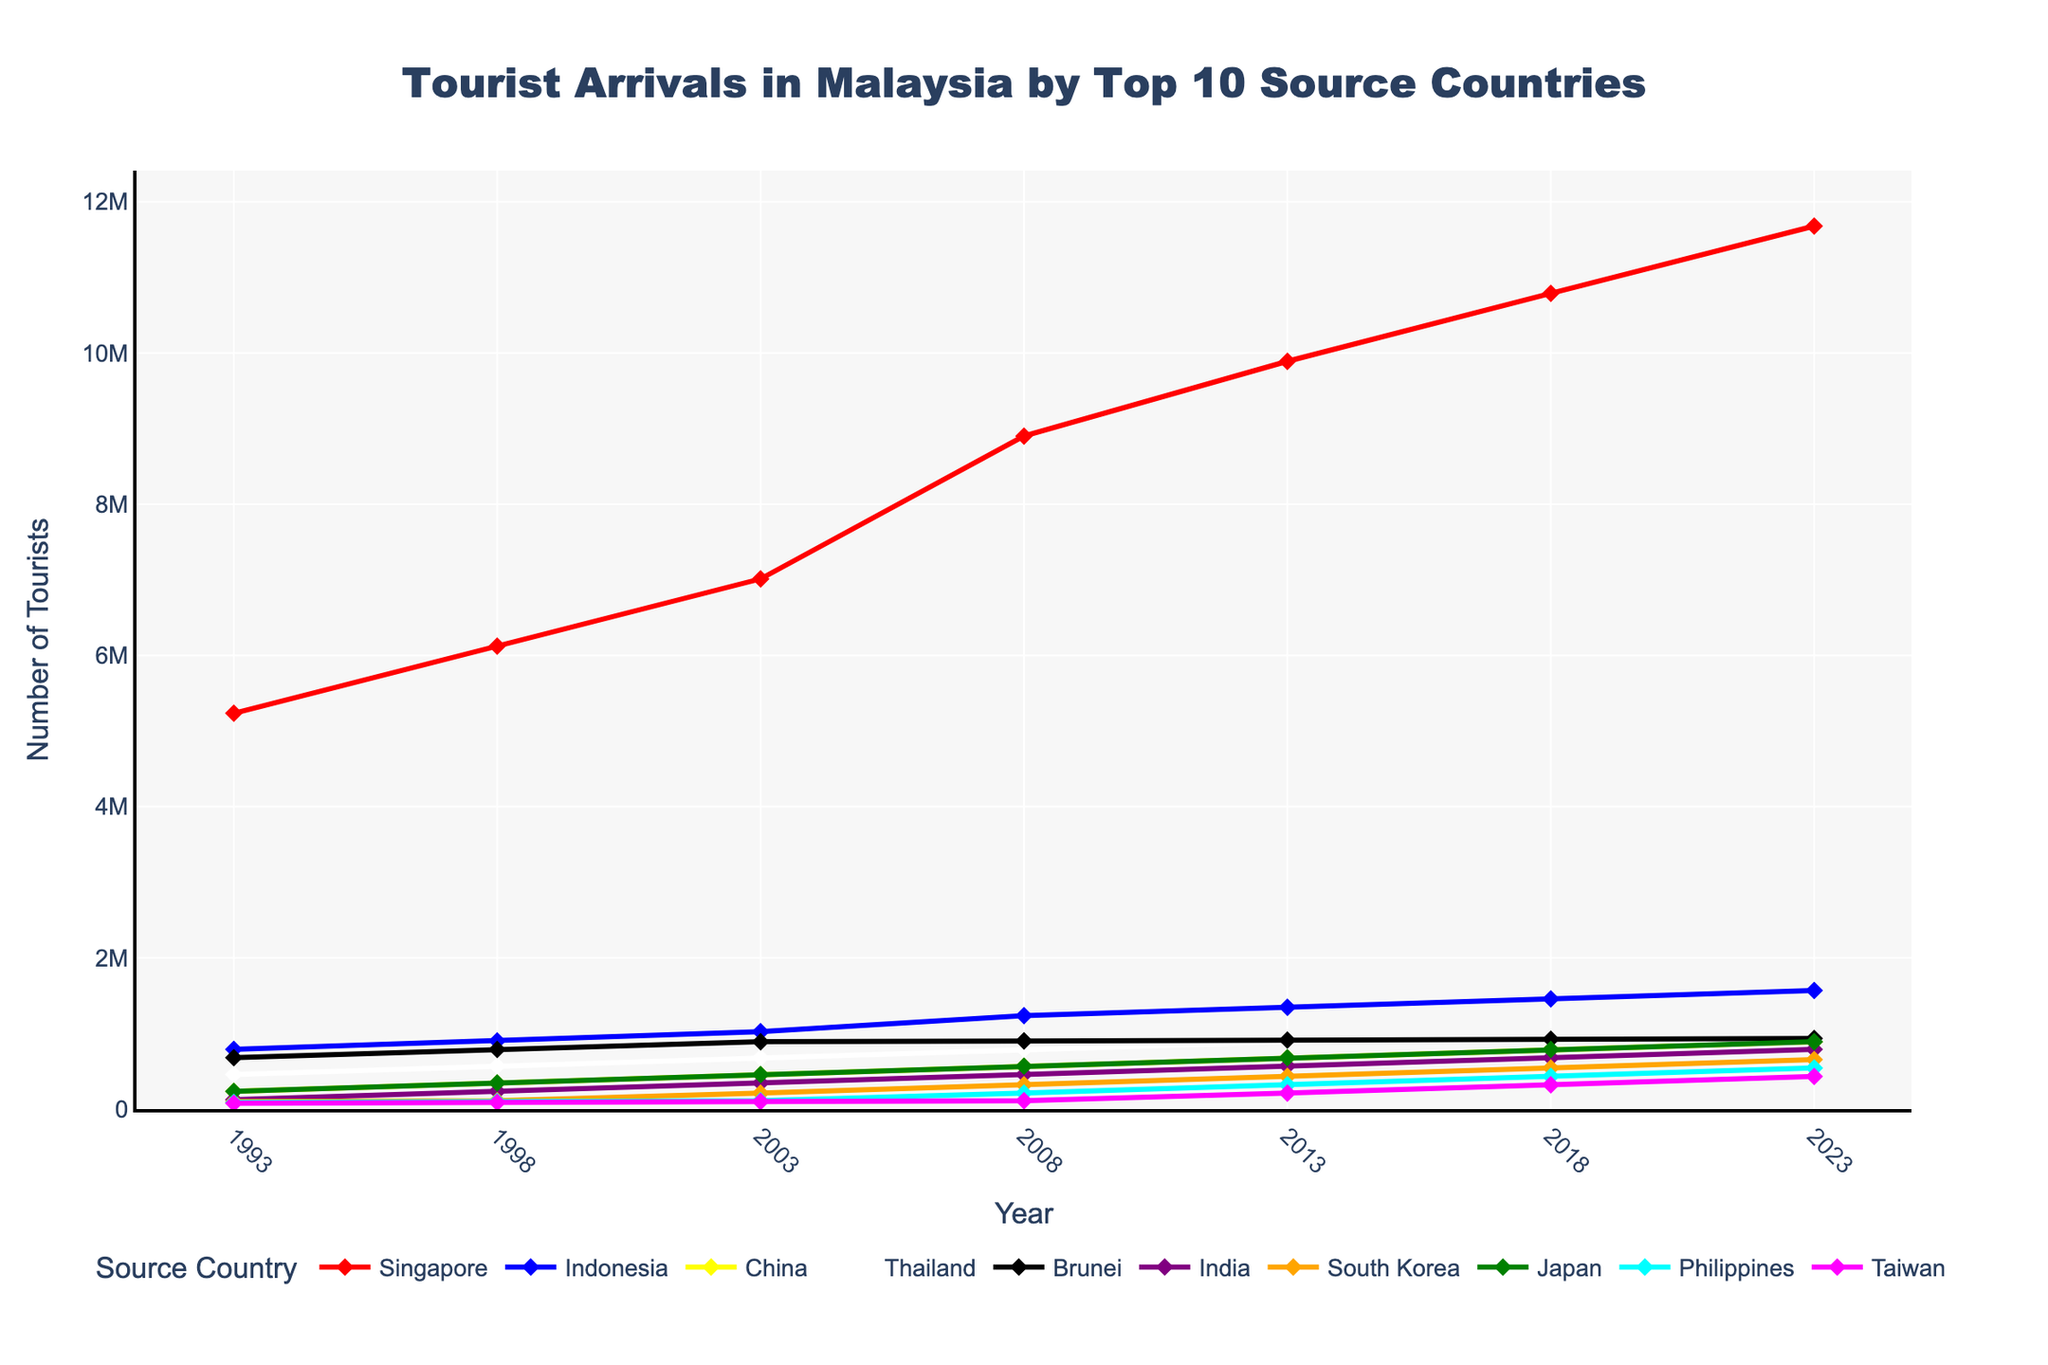Which country had the highest number of tourist arrivals in 2023? Looking at the figure for the year 2023, the line for Singapore is at the highest position, indicating the most tourist arrivals.
Answer: Singapore How did the number of tourists from Indonesia change from 1993 to 2003? In 1993, Indonesia had 789123 tourists, and in 2003 it had 1023456 tourists. The change is 1023456 - 789123 = 234333.
Answer: Increased by 234333 What is the average number of tourists from China over the given years? Sum the number of tourists from China for each provided year (234567 + 345678 + 456789 + 567890 + 678901 + 789012 + 890123) and divide by the number of years (7). (234567 + 345678 + 456789 + 567890 + 678901 + 789012 + 890123) / 7 = 4377371 / 7.
Answer: 625339 Which country had a higher increase in tourist arrivals from 2013 to 2023: Thailand or South Korea? For Thailand: 912345 in 2023 - 890123 in 2013 = 22222. For South Korea: 654321 in 2023 - 432109 in 2013 = 222212.
Answer: South Korea During which year did the Philippines surpass 100,000 tourist arrivals? Looking at the line representing the Philippines, the value surpasses 100,000 in the year 2003.
Answer: 2003 Compare the number of tourists from Brunei and Japan in 2018. Which was higher and by how much? In 2018, Brunei had 923456, and Japan had 789012 tourists. The difference is 923456 - 789012 = 134444.
Answer: Brunei, by 134444 From 1998 to 2008, which country experienced the largest growth in tourist numbers? Comparing tourist numbers for each country in 1998 and 2008: 
Singapore: 8901234 - 6123456 = 2777778
Indonesia: 1234567 - 901234 = 333333
China: 567890 - 345678 = 222212
Thailand: 789012 - 567890 = 221122
Brunei: 901234 - 789012 = 112222
India: 456789 - 234567 = 222222
South Korea: 321098 - 109876 = 211222
Japan: 567890 - 345678 = 222212
Philippines: 210987 - 98765 = 112222
Taiwan: 109876 - 87654 = 22222
The largest growth in tourist numbers is for Singapore with 2777778.
Answer: Singapore Which country had the lowest tourist arrivals in the year 1993? In 1993, the country with the lowest number of tourist arrivals, based on the figure, is Taiwan with 76543 tourists.
Answer: Taiwan 